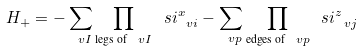Convert formula to latex. <formula><loc_0><loc_0><loc_500><loc_500>H _ { + } = - \sum _ { \ v I } \prod _ { \text {legs of } \ v I } \ s i _ { \ v i } ^ { x } - \sum _ { \ v p } \prod _ { \text {edges of } \ v p } \ s i ^ { z } _ { \ v j }</formula> 